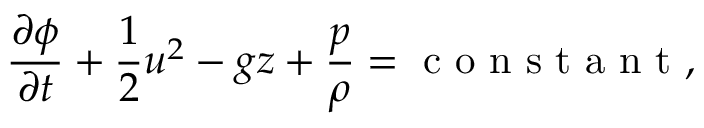<formula> <loc_0><loc_0><loc_500><loc_500>\frac { \partial \phi } { \partial t } + \frac { 1 } { 2 } u ^ { 2 } - g z + \frac { p } { \rho } = c o n s t a n t ,</formula> 